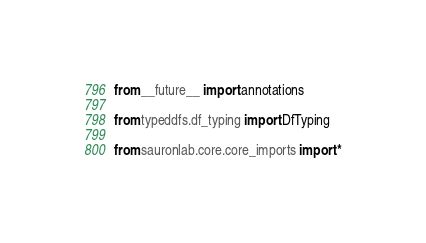<code> <loc_0><loc_0><loc_500><loc_500><_Python_>from __future__ import annotations

from typeddfs.df_typing import DfTyping

from sauronlab.core.core_imports import *</code> 